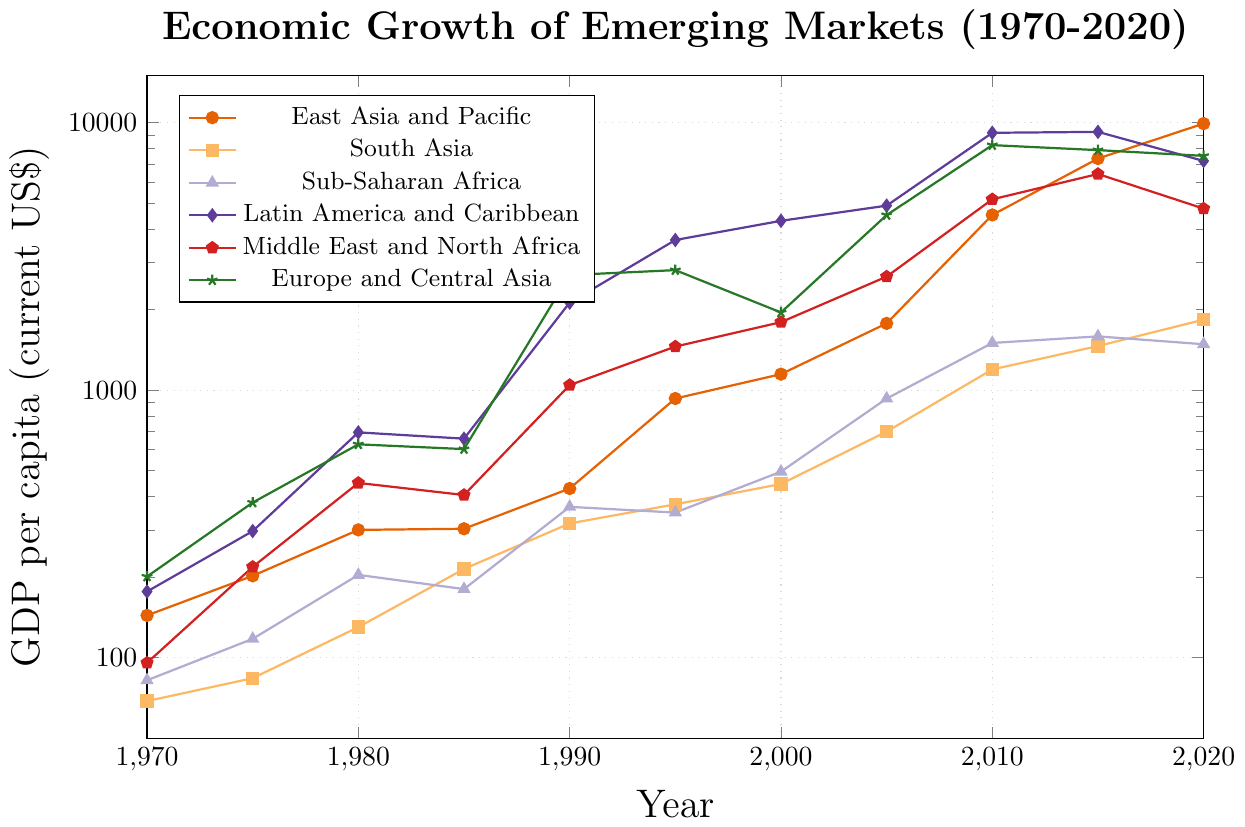What is the overall trend in GDP per capita for Latin America and Caribbean from 1970 to 2020? Over the period from 1970 to 2020, the GDP per capita for Latin America and Caribbean increases significantly. It starts at 176.76 in 1970 and reaches 7189.23 in 2020. This reflects robust economic growth over the 50-year span.
Answer: Significant increase Which region had the highest GDP per capita in 2010? To determine the highest GDP per capita in 2010, we compare the 2010 values for all regions: East Asia and Pacific (4516.23), South Asia (1195.34), Sub-Saharan Africa (1501.23), Latin America and Caribbean (9156.78), Middle East and North Africa (5165.45), and Europe and Central Asia (8234.56). Latin America and Caribbean had the highest value.
Answer: Latin America and Caribbean In which decade did East Asia and Pacific experience the most significant GDP growth? We examine the GDP per capita values for East Asia and Pacific across different decades: 143.97 (1970), 428.96 (1990), 1776.45 (2000), 4516.23 (2010), and 9912.34 (2020). Calculating the growth for each decade, the most significant increase is observed from 2000 to 2010 (4516.23 - 1776.45 ≈ 2739.78).
Answer: 2000-2010 Which regions had a GDP per capita below 1000 in 2020? We look at the 2020 GDP per capita values and identify which are below 1000: East Asia and Pacific (9912.34), South Asia (1834.56), Sub-Saharan Africa (1484.67), Latin America and Caribbean (7189.23), Middle East and North Africa (4769.45), Europe and Central Asia (7509.78). None of the regions have GDP per capita below 1000 in 2020.
Answer: None Compare the GDP per capita growth rates between South Asia and Sub-Saharan Africa from 1970 to 2020. Which region had a higher growth rate? We calculate the ratio of GDP per capita in 2020 to 1970 for each region: South Asia: 1834.56 / 68.89 ≈ 26.63, Sub-Saharan Africa: 1484.67 / 82.39 ≈ 18.02. South Asia had a higher growth rate over this period.
Answer: South Asia Between the years 1990 and 2000, did any region experience a decrease in GDP per capita? Reviewing the GDP per capita values from 1990 to 2000 for each region: East Asia and Pacific (428.96 to 1147.79), South Asia (317.73 to 445.98), Sub-Saharan Africa (366.39 to 496.04), Latin America and Caribbean (2124.35 to 4293.65), Middle East and North Africa (1044.67 to 1795.34), Europe and Central Asia (2692.56 to 1951.78). Only Europe and Central Asia saw a decrease from 2692.56 to 1951.78.
Answer: Europe and Central Asia What was the GDP per capita of the region represented by the green line in 1980? By referring to the chart's legend, we identify the green line as representing Europe and Central Asia. The GDP per capita for this region in 1980 is 627.45.
Answer: 627.45 Which region had the second highest GDP per capita in 2020 and what was its value? We compare the GDP per capita values for 2020: East Asia and Pacific (9912.34), South Asia (1834.56), Sub-Saharan Africa (1484.67), Latin America and Caribbean (7189.23), Middle East and North Africa (4769.45), and Europe and Central Asia (7509.78). Europe and Central Asia had the second highest with 7509.78.
Answer: Europe and Central Asia, 7509.78 